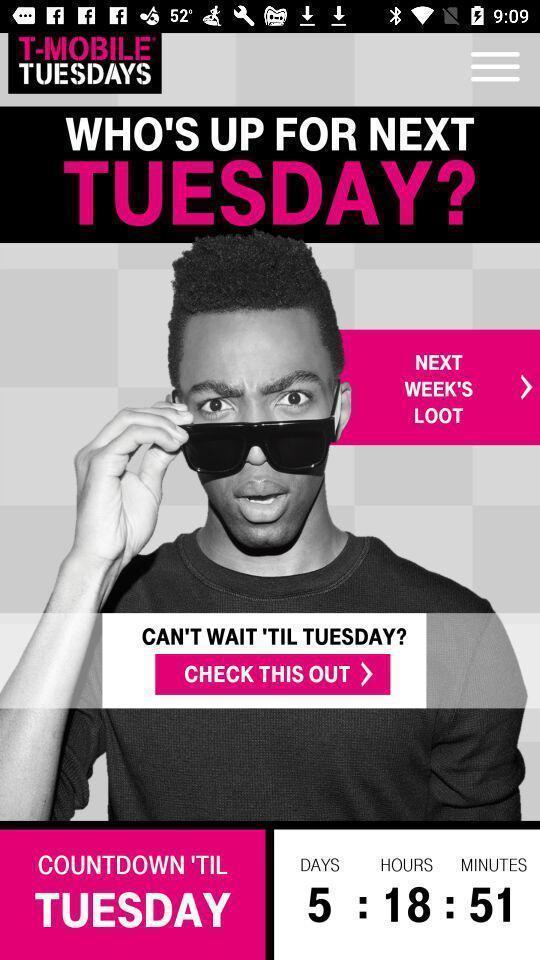Describe the content in this image. Welcome page of a online shopping application. 